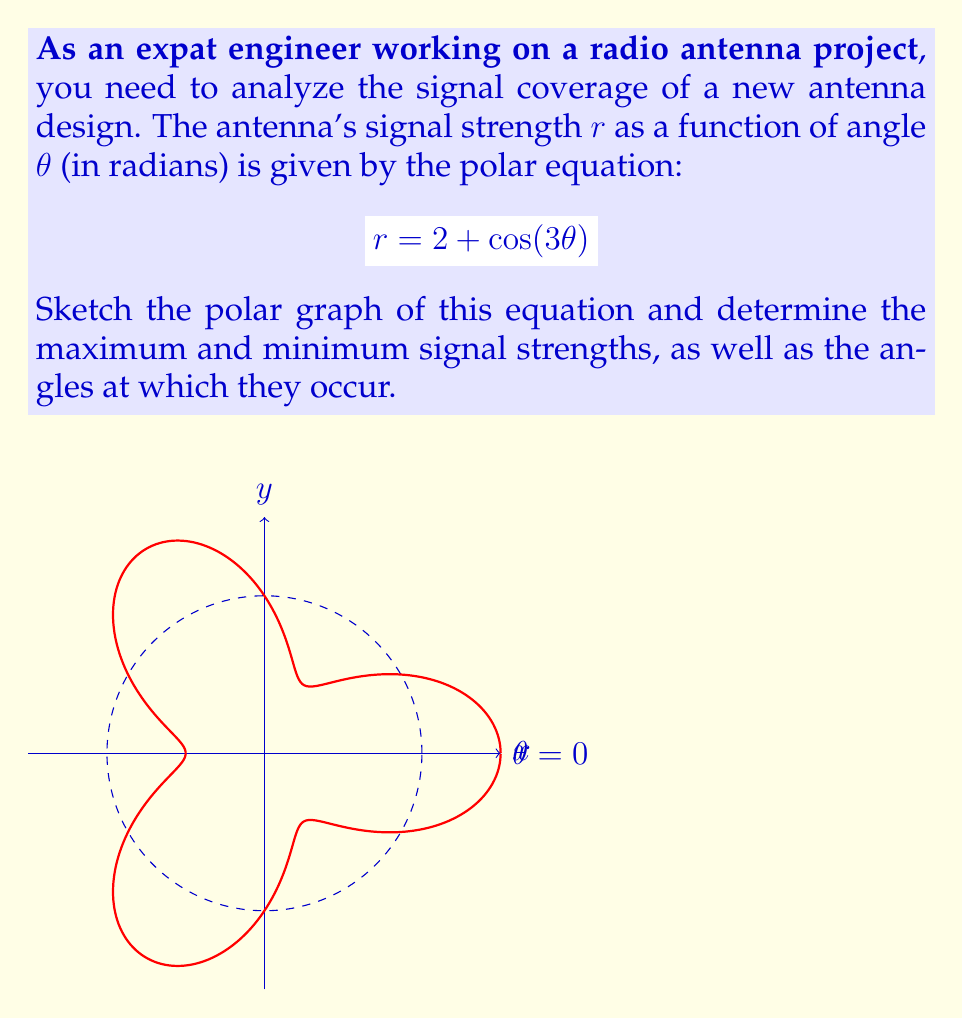Could you help me with this problem? Let's approach this step-by-step:

1) To sketch the graph, we need to understand the equation $r = 2 + \cos(3\theta)$:
   - The constant term 2 shifts the entire graph outward from the origin.
   - The $\cos(3\theta)$ term causes the graph to oscillate around this shifted circle.
   - The factor 3 in $\cos(3\theta)$ means the graph will complete 3 full oscillations in $2\pi$ radians.

2) To find the maximum and minimum signal strengths:
   - The maximum occurs when $\cos(3\theta) = 1$, giving $r_{max} = 2 + 1 = 3$
   - The minimum occurs when $\cos(3\theta) = -1$, giving $r_{min} = 2 - 1 = 1$

3) To find the angles at which these occur:
   - For the maximum: $\cos(3\theta) = 1$ when $3\theta = 0, 2\pi, 4\pi, ...$
     So $\theta = 0, \frac{2\pi}{3}, \frac{4\pi}{3}$ (in the range $[0, 2\pi]$)
   - For the minimum: $\cos(3\theta) = -1$ when $3\theta = \pi, 3\pi, 5\pi, ...$
     So $\theta = \frac{\pi}{3}, \pi, \frac{5\pi}{3}$ (in the range $[0, 2\pi]$)

4) The graph (as shown in the question) confirms these findings:
   - It has 3 "petals" corresponding to the 3 maxima
   - It has 3 indentations corresponding to the 3 minima
   - The graph oscillates between $r = 1$ and $r = 3$
Answer: Max strength: 3 at $\theta = 0, \frac{2\pi}{3}, \frac{4\pi}{3}$; Min strength: 1 at $\theta = \frac{\pi}{3}, \pi, \frac{5\pi}{3}$ 